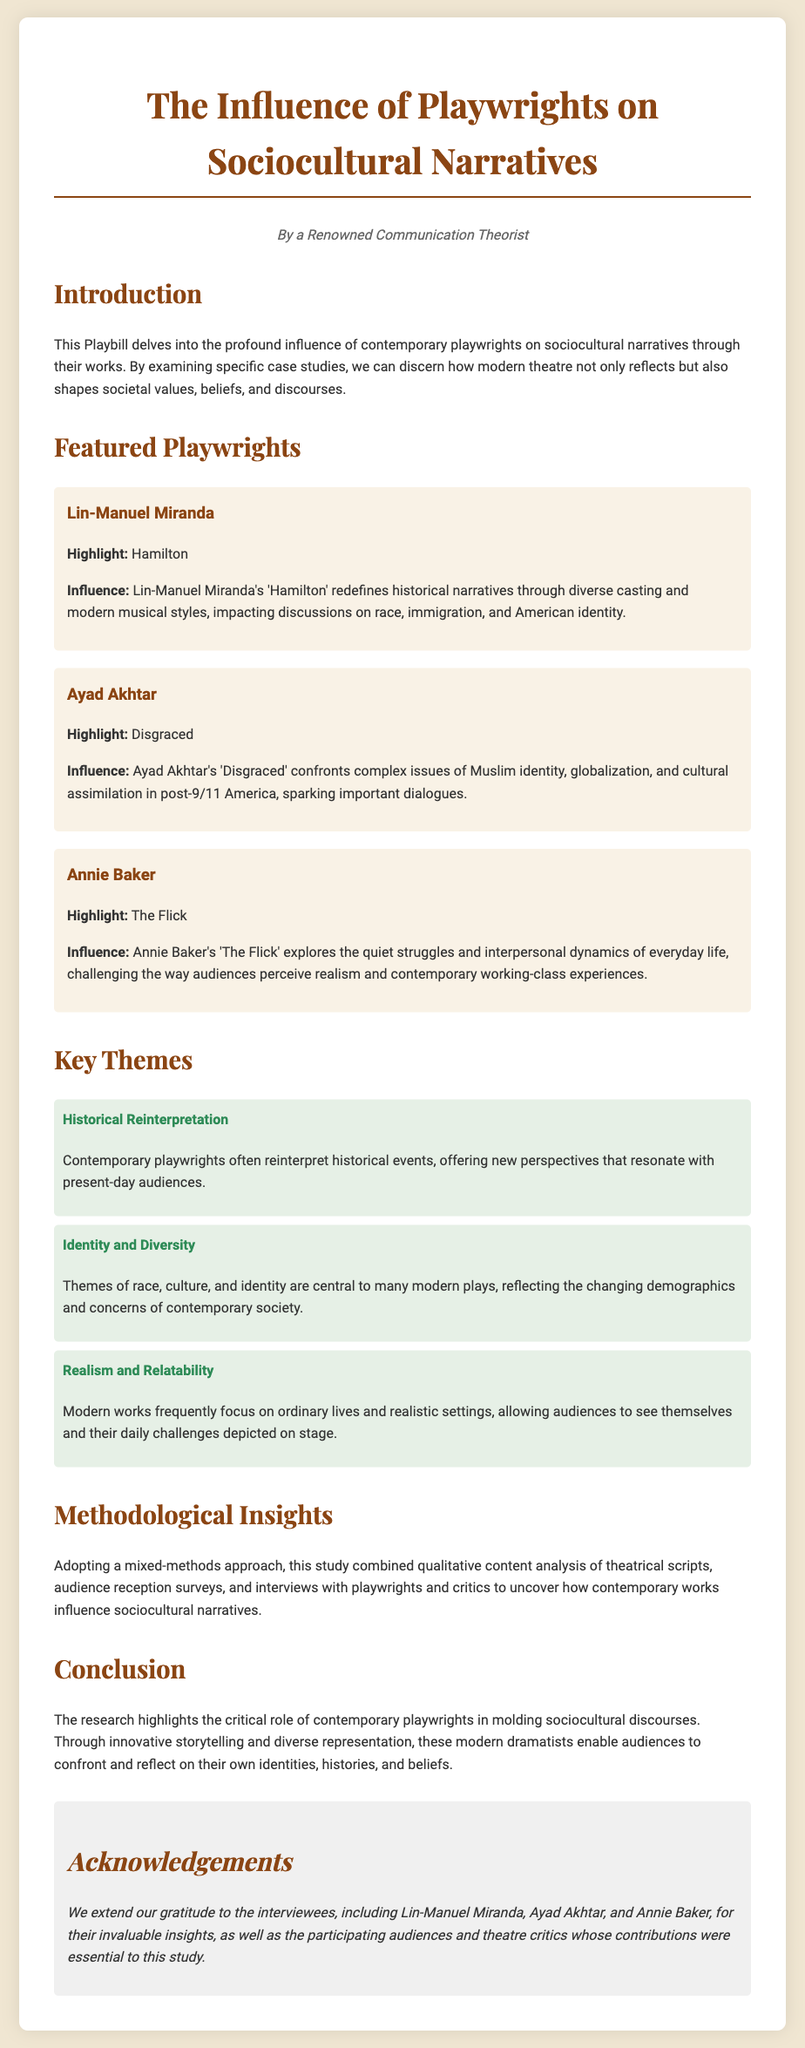What is the title of the Playbill? The title of the Playbill is prominently displayed at the top of the document, indicating the main focus of its content.
Answer: The Influence of Playwrights on Sociocultural Narratives Who is the first featured playwright? The document lists several playwrights, and the first one mentioned is identified by name as part of the featured playwrights section.
Answer: Lin-Manuel Miranda What is the highlight work of Ayad Akhtar? The Playbill specifies the important work associated with each featured playwright, noting that Ayad Akhtar's highlight is provided.
Answer: Disgraced Which theme involves the reinterpretation of historical events? The document categorizes themes discussed within contemporary works, with one specifically dedicated to a type of narrative approach.
Answer: Historical Reinterpretation How many playwrights are featured in the Playbill? The number of featured playwrights is determined by counting the individual sections dedicated to each playwright's contributions in the document.
Answer: Three 